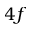Convert formula to latex. <formula><loc_0><loc_0><loc_500><loc_500>4 f</formula> 